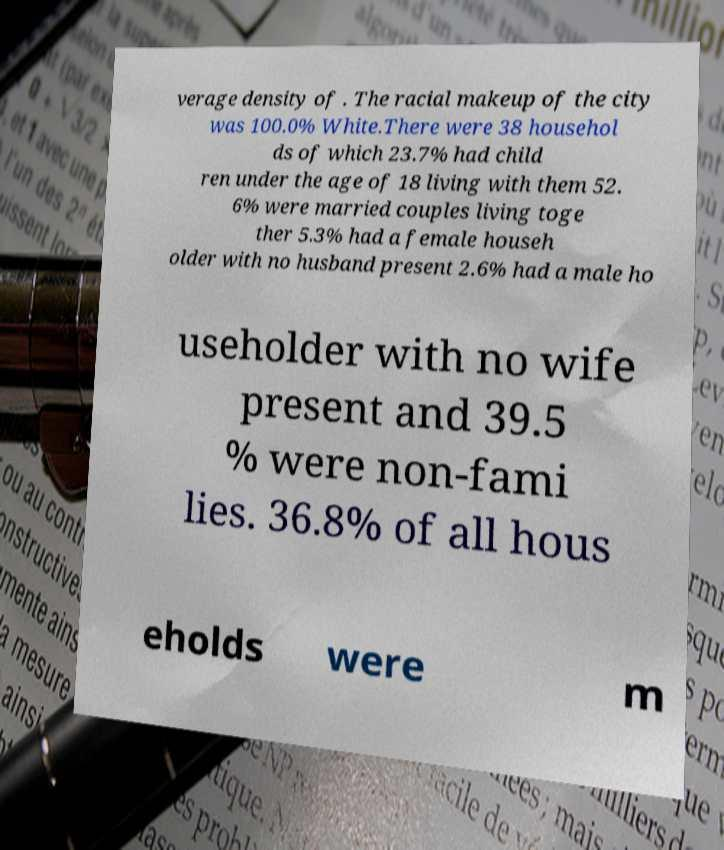Please identify and transcribe the text found in this image. verage density of . The racial makeup of the city was 100.0% White.There were 38 househol ds of which 23.7% had child ren under the age of 18 living with them 52. 6% were married couples living toge ther 5.3% had a female househ older with no husband present 2.6% had a male ho useholder with no wife present and 39.5 % were non-fami lies. 36.8% of all hous eholds were m 